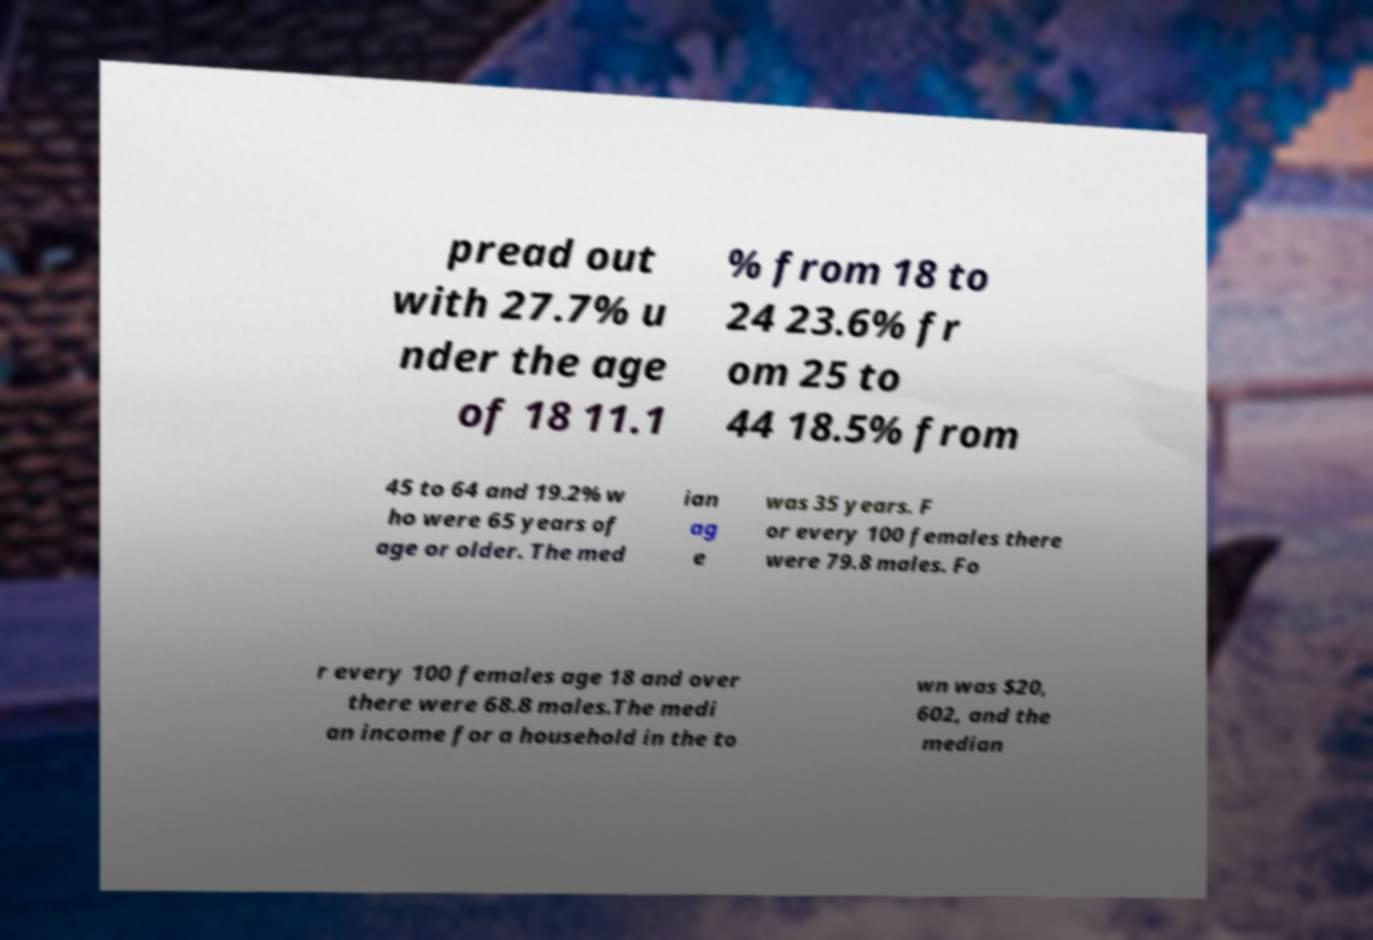Can you accurately transcribe the text from the provided image for me? pread out with 27.7% u nder the age of 18 11.1 % from 18 to 24 23.6% fr om 25 to 44 18.5% from 45 to 64 and 19.2% w ho were 65 years of age or older. The med ian ag e was 35 years. F or every 100 females there were 79.8 males. Fo r every 100 females age 18 and over there were 68.8 males.The medi an income for a household in the to wn was $20, 602, and the median 